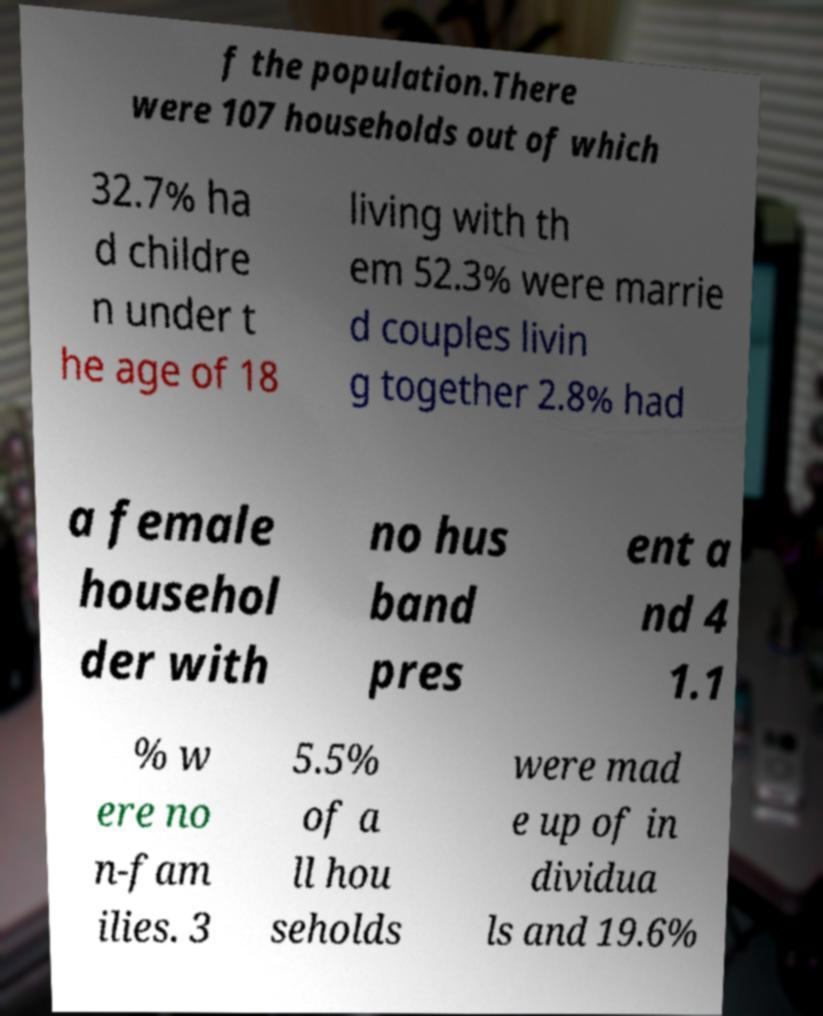What messages or text are displayed in this image? I need them in a readable, typed format. f the population.There were 107 households out of which 32.7% ha d childre n under t he age of 18 living with th em 52.3% were marrie d couples livin g together 2.8% had a female househol der with no hus band pres ent a nd 4 1.1 % w ere no n-fam ilies. 3 5.5% of a ll hou seholds were mad e up of in dividua ls and 19.6% 